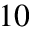<formula> <loc_0><loc_0><loc_500><loc_500>1 0</formula> 